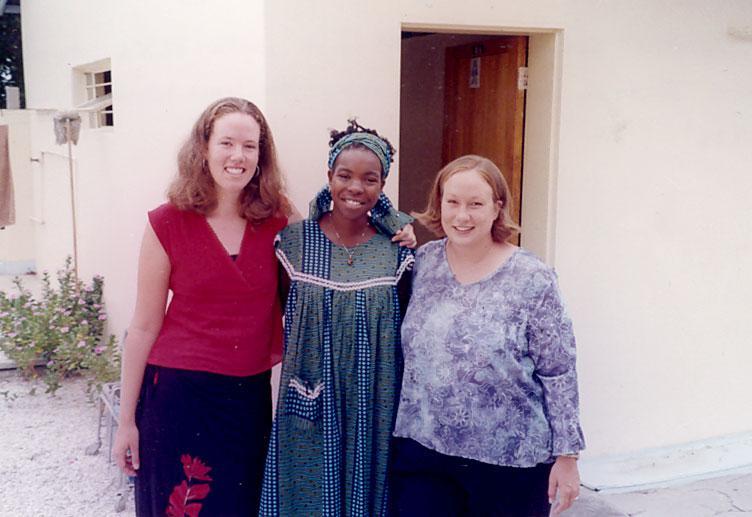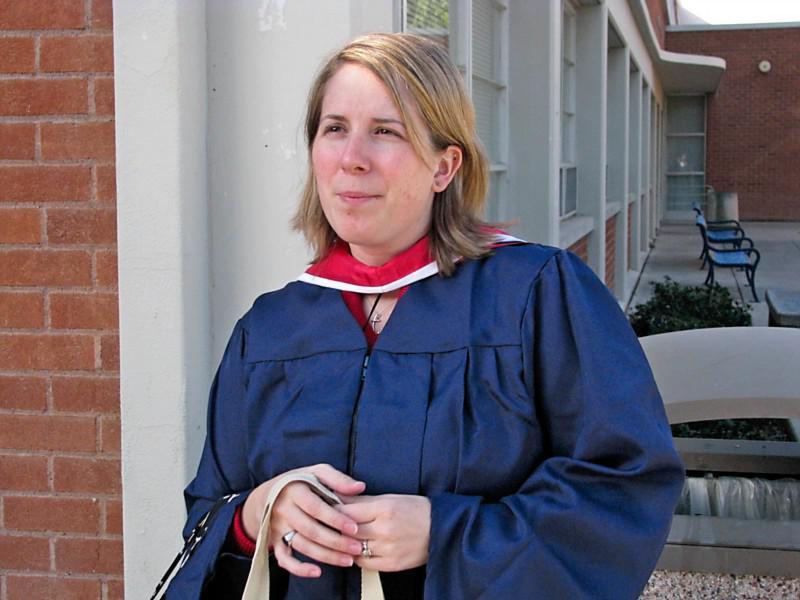The first image is the image on the left, the second image is the image on the right. Assess this claim about the two images: "The left image contains no more than two humans.". Correct or not? Answer yes or no. No. The first image is the image on the left, the second image is the image on the right. Examine the images to the left and right. Is the description "One image includes at least one male in a royal blue graduation gown and cap, and the other image contains no male graduates." accurate? Answer yes or no. No. 